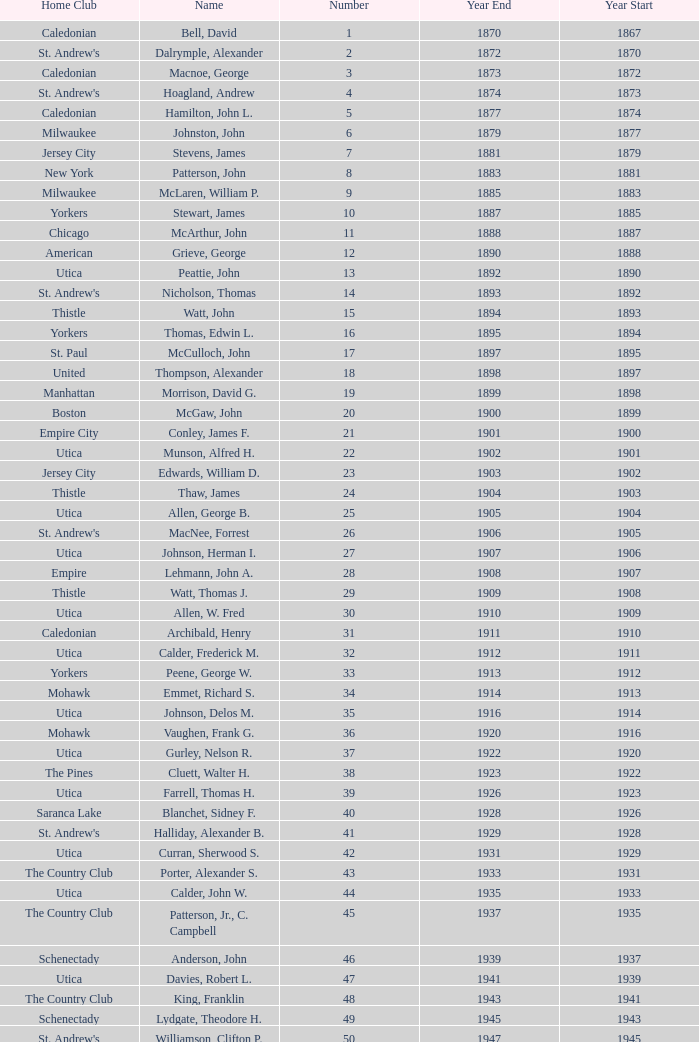Which Year Start has a Number of 28? 1907.0. 